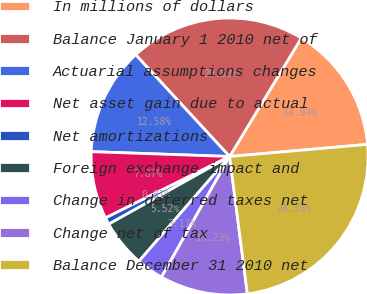Convert chart. <chart><loc_0><loc_0><loc_500><loc_500><pie_chart><fcel>In millions of dollars<fcel>Balance January 1 2010 net of<fcel>Actuarial assumptions changes<fcel>Net asset gain due to actual<fcel>Net amortizations<fcel>Foreign exchange impact and<fcel>Change in deferred taxes net<fcel>Change net of tax<fcel>Balance December 31 2010 net<nl><fcel>14.94%<fcel>20.53%<fcel>12.58%<fcel>7.87%<fcel>0.81%<fcel>5.52%<fcel>3.17%<fcel>10.23%<fcel>24.35%<nl></chart> 